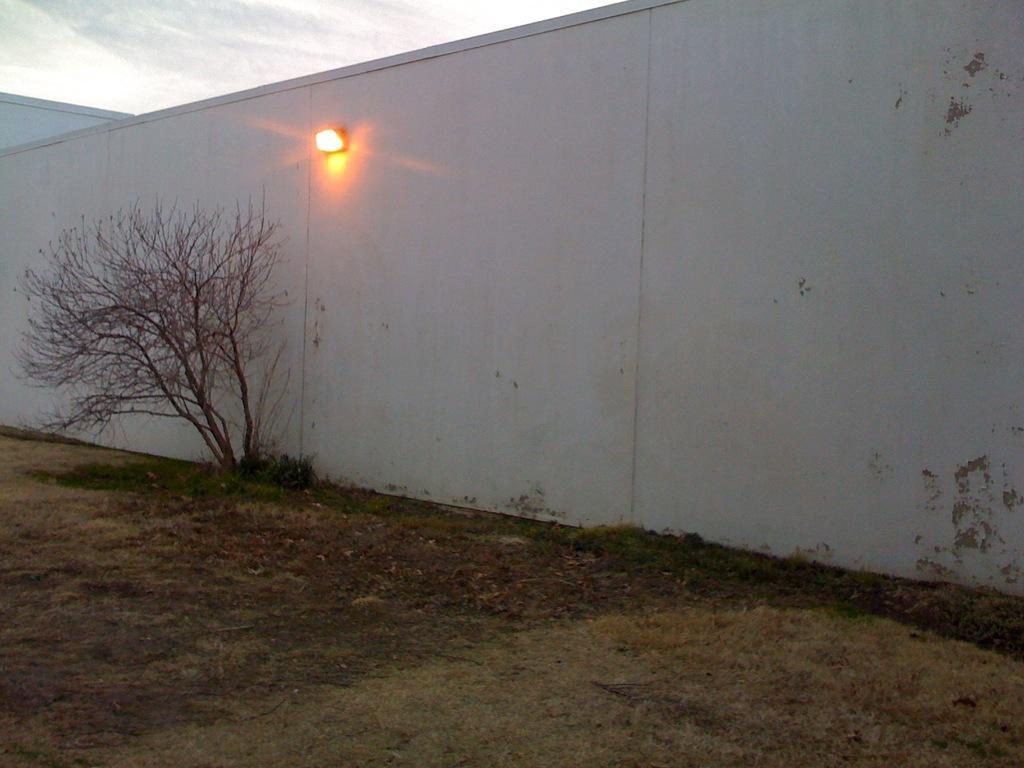Can you describe this image briefly? In this image we can see plants and grass on the ground at the wall and there is a light on the wall. In the background we can see clouds in the sky. 